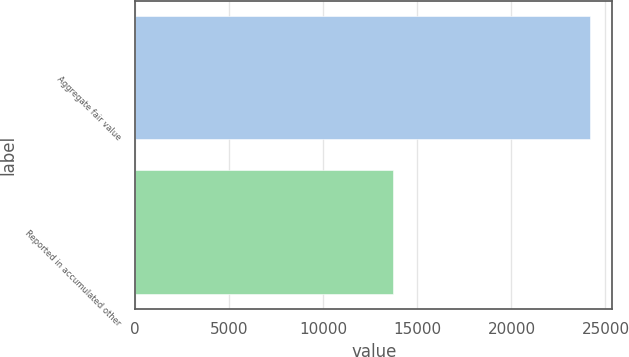Convert chart to OTSL. <chart><loc_0><loc_0><loc_500><loc_500><bar_chart><fcel>Aggregate fair value<fcel>Reported in accumulated other<nl><fcel>24151<fcel>13678<nl></chart> 